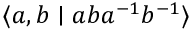<formula> <loc_0><loc_0><loc_500><loc_500>\langle a , b | a b a ^ { - 1 } b ^ { - 1 } \rangle</formula> 